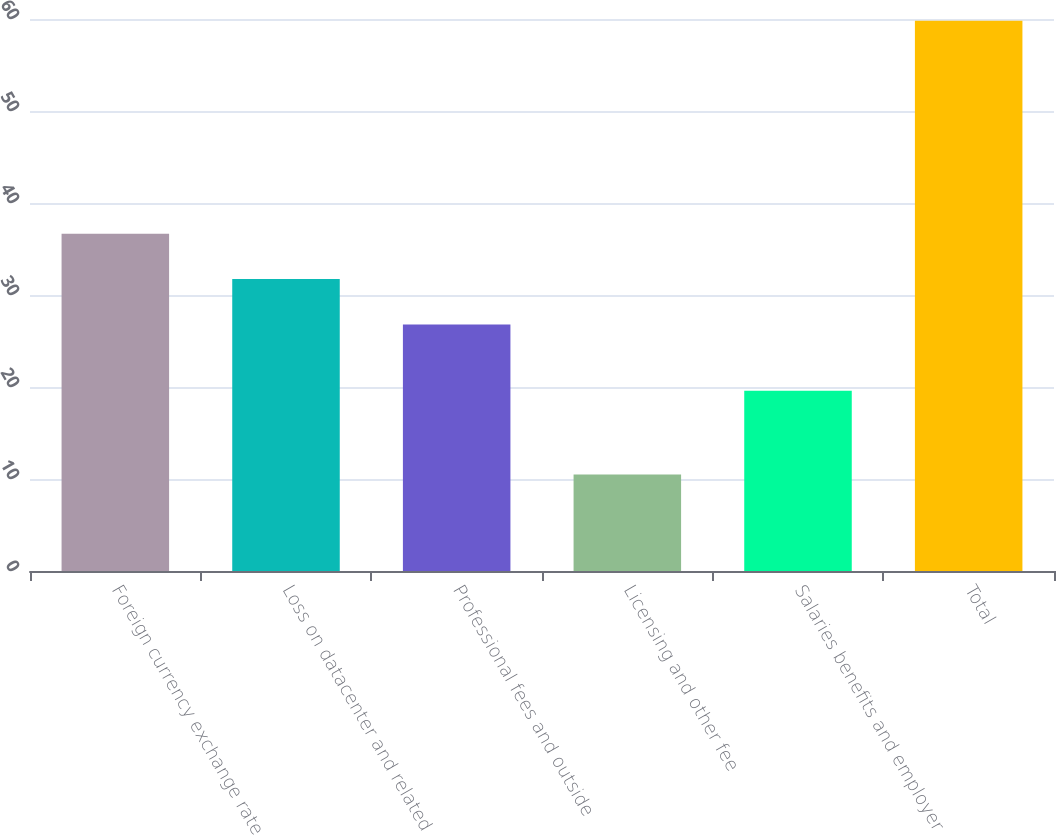<chart> <loc_0><loc_0><loc_500><loc_500><bar_chart><fcel>Foreign currency exchange rate<fcel>Loss on datacenter and related<fcel>Professional fees and outside<fcel>Licensing and other fee<fcel>Salaries benefits and employer<fcel>Total<nl><fcel>36.66<fcel>31.73<fcel>26.8<fcel>10.5<fcel>19.6<fcel>59.8<nl></chart> 